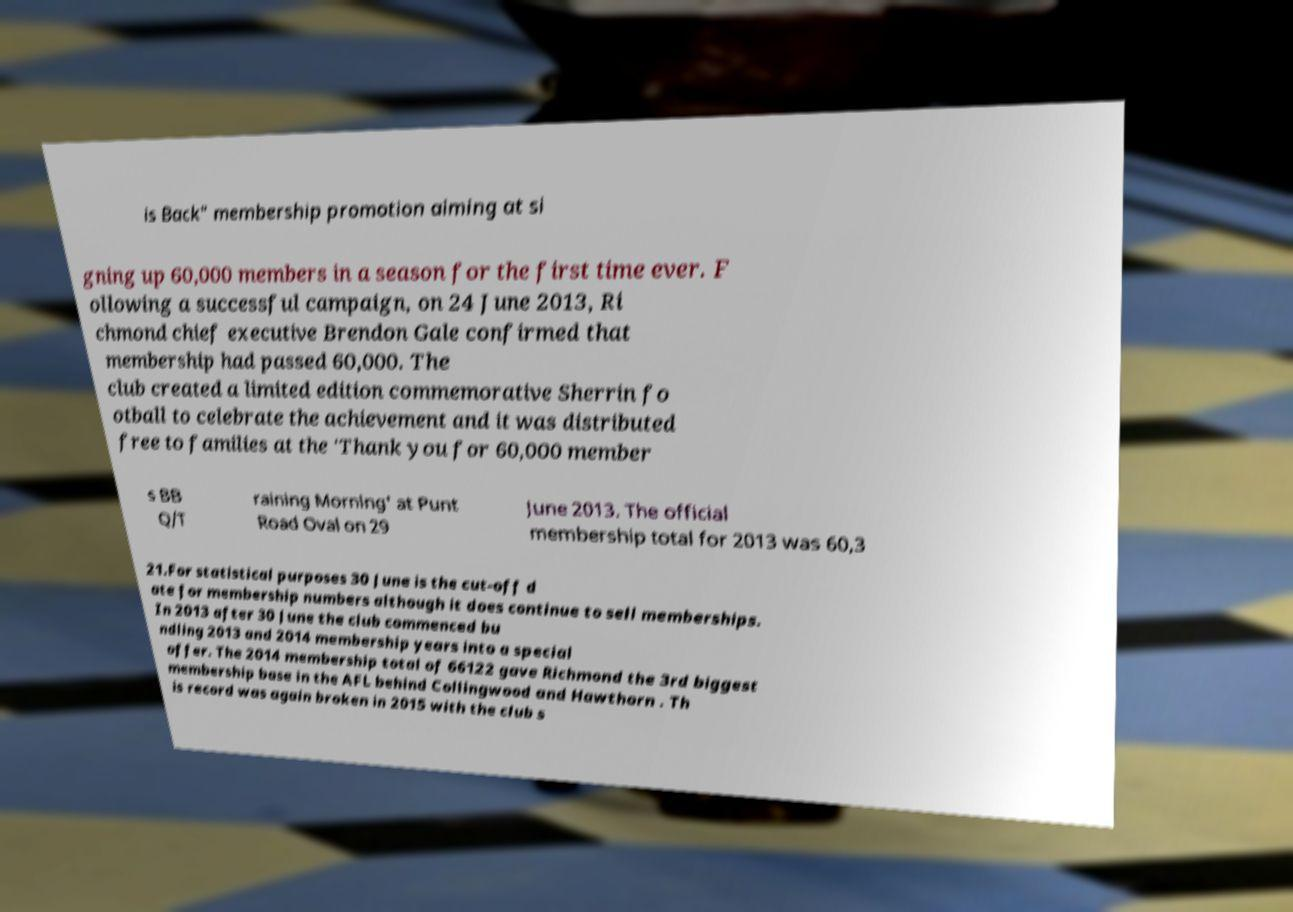I need the written content from this picture converted into text. Can you do that? is Back" membership promotion aiming at si gning up 60,000 members in a season for the first time ever. F ollowing a successful campaign, on 24 June 2013, Ri chmond chief executive Brendon Gale confirmed that membership had passed 60,000. The club created a limited edition commemorative Sherrin fo otball to celebrate the achievement and it was distributed free to families at the 'Thank you for 60,000 member s BB Q/T raining Morning' at Punt Road Oval on 29 June 2013. The official membership total for 2013 was 60,3 21.For statistical purposes 30 June is the cut-off d ate for membership numbers although it does continue to sell memberships. In 2013 after 30 June the club commenced bu ndling 2013 and 2014 membership years into a special offer. The 2014 membership total of 66122 gave Richmond the 3rd biggest membership base in the AFL behind Collingwood and Hawthorn . Th is record was again broken in 2015 with the club s 